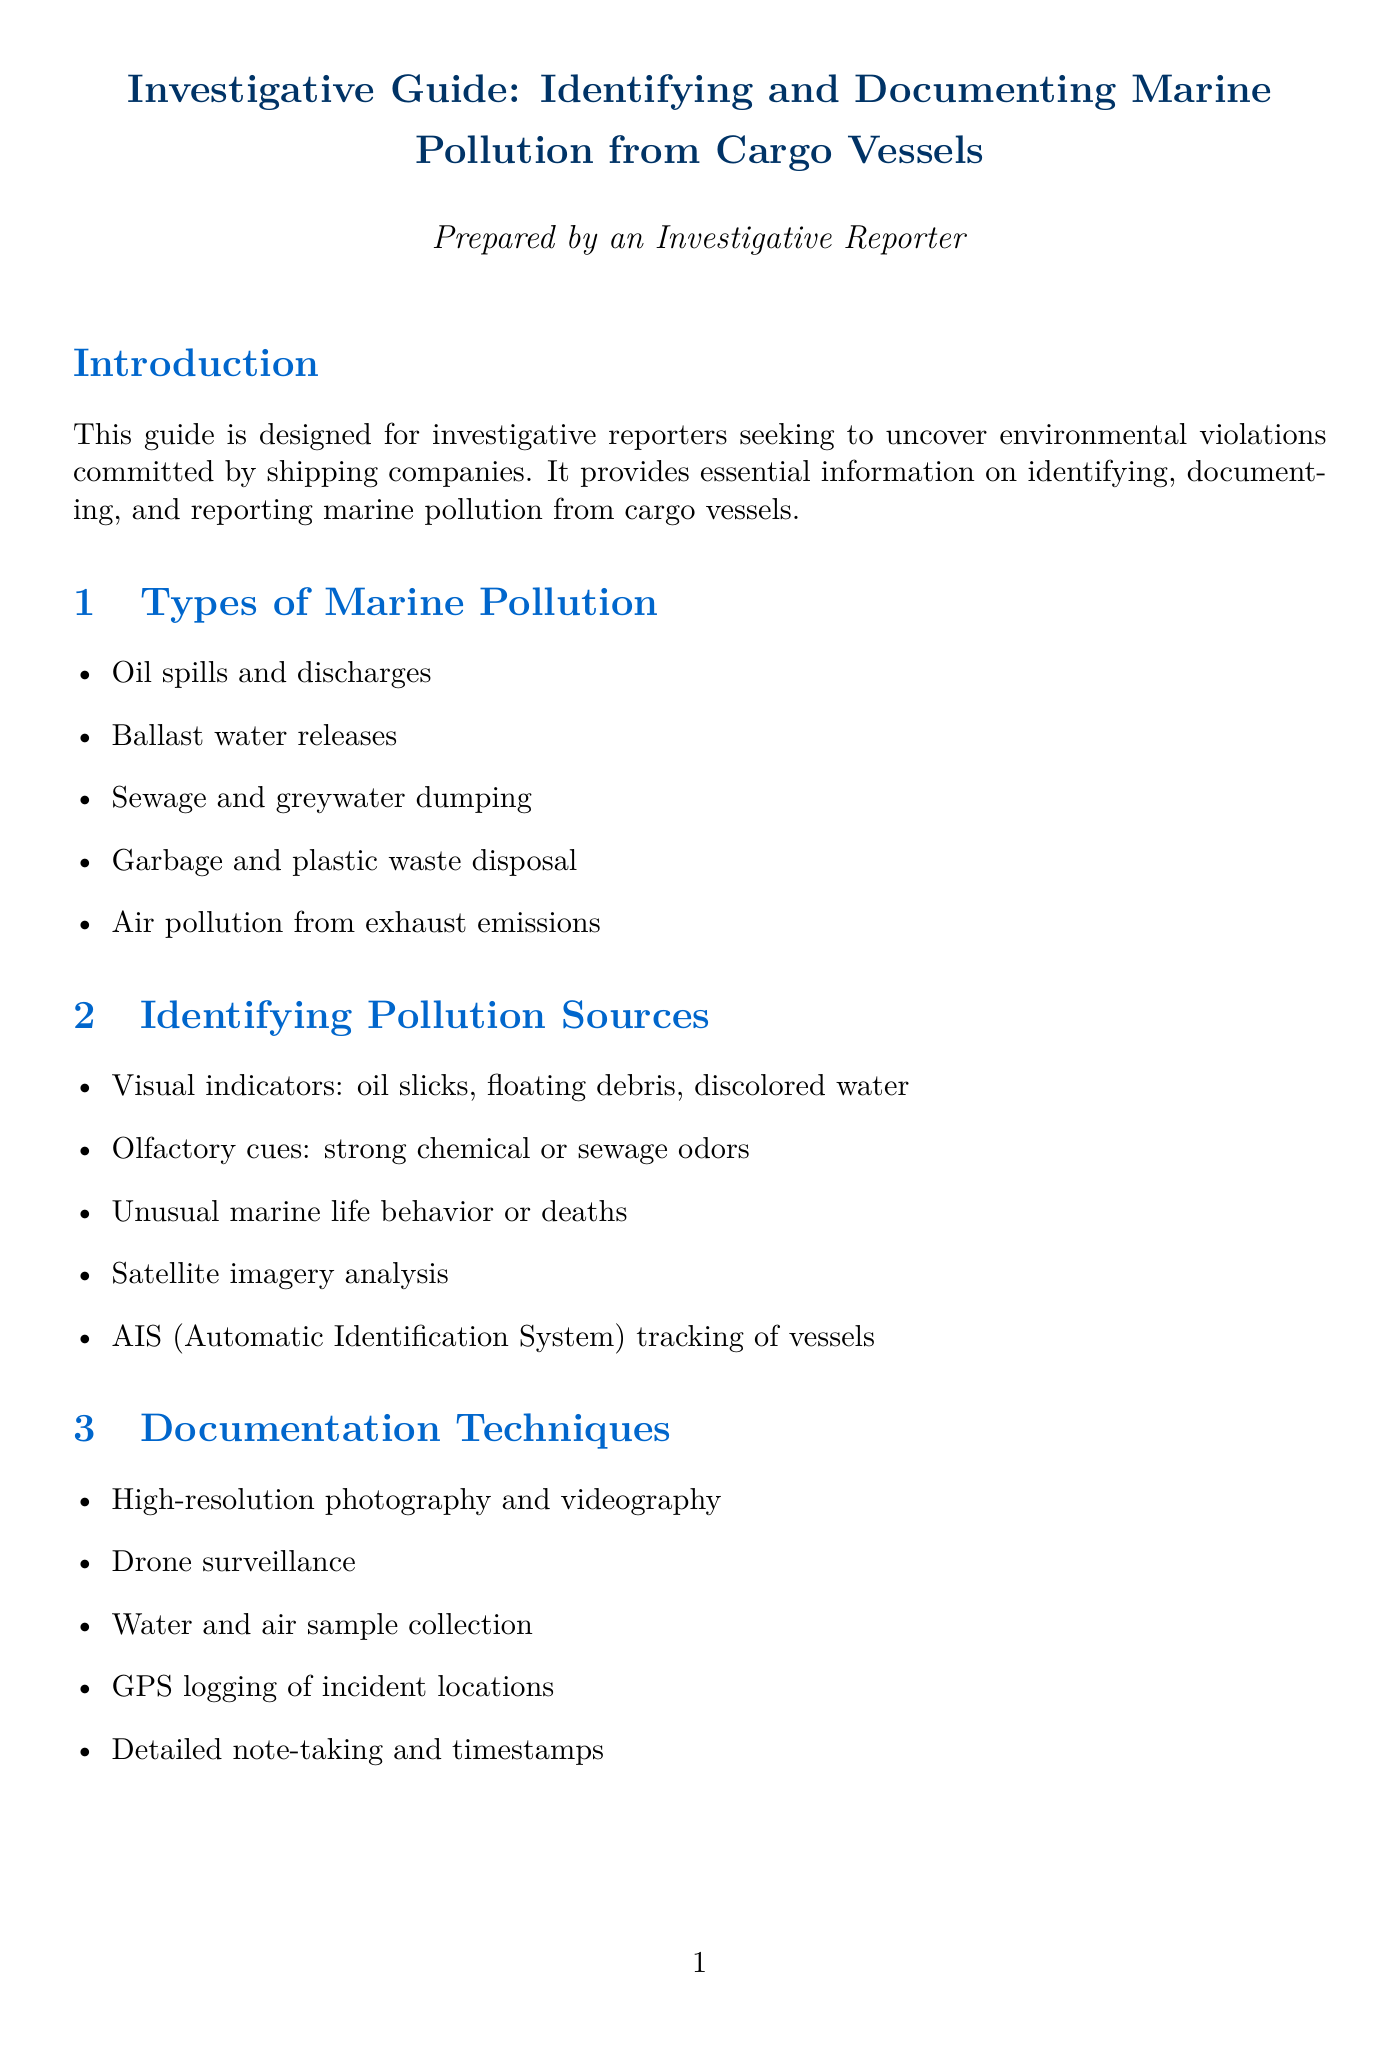What is the main purpose of the guide? The guide is designed for investigative reporters seeking to uncover environmental violations committed by shipping companies.
Answer: Investigative reporters What are the types of marine pollution listed? The document lists several types of marine pollution, including oil spills, ballast water releases, and more.
Answer: Oil spills and discharges, Ballast water releases, Sewage and greywater dumping, Garbage and plastic waste disposal, Air pollution from exhaust emissions Which equipment is recommended for photography? The specific equipment recommended for high-resolution photography in the guide is mentioned.
Answer: Canon EOS R5 camera with telephoto lens What legal act is specifically related to preventing pollution from ships? This act is critical in the legal framework for reporting marine pollution.
Answer: Act to Prevent Pollution from Ships (APPS) How many case studies are mentioned? The number of case studies discussed in the document regarding marine pollution violations is noted.
Answer: Three Which investigative strategy involves monitoring traffic? The strategy related to vessel traffic in high-risk areas is stated in the investigative strategies section.
Answer: Monitoring vessel traffic in high-risk areas What type of sample collection is mentioned for documentation? This refers to the types of samples that can be collected to document marine pollution incidents.
Answer: Water and air sample collection What protective measure is advised for hazardous environments? The guide suggests a specific safety precaution for those working in potentially dangerous situations.
Answer: Personal protective equipment What organization is suggested for whistleblowing? The document highlights a specific organization to contact for reporting pollution incidents.
Answer: U.S. Coast Guard National Response Center 